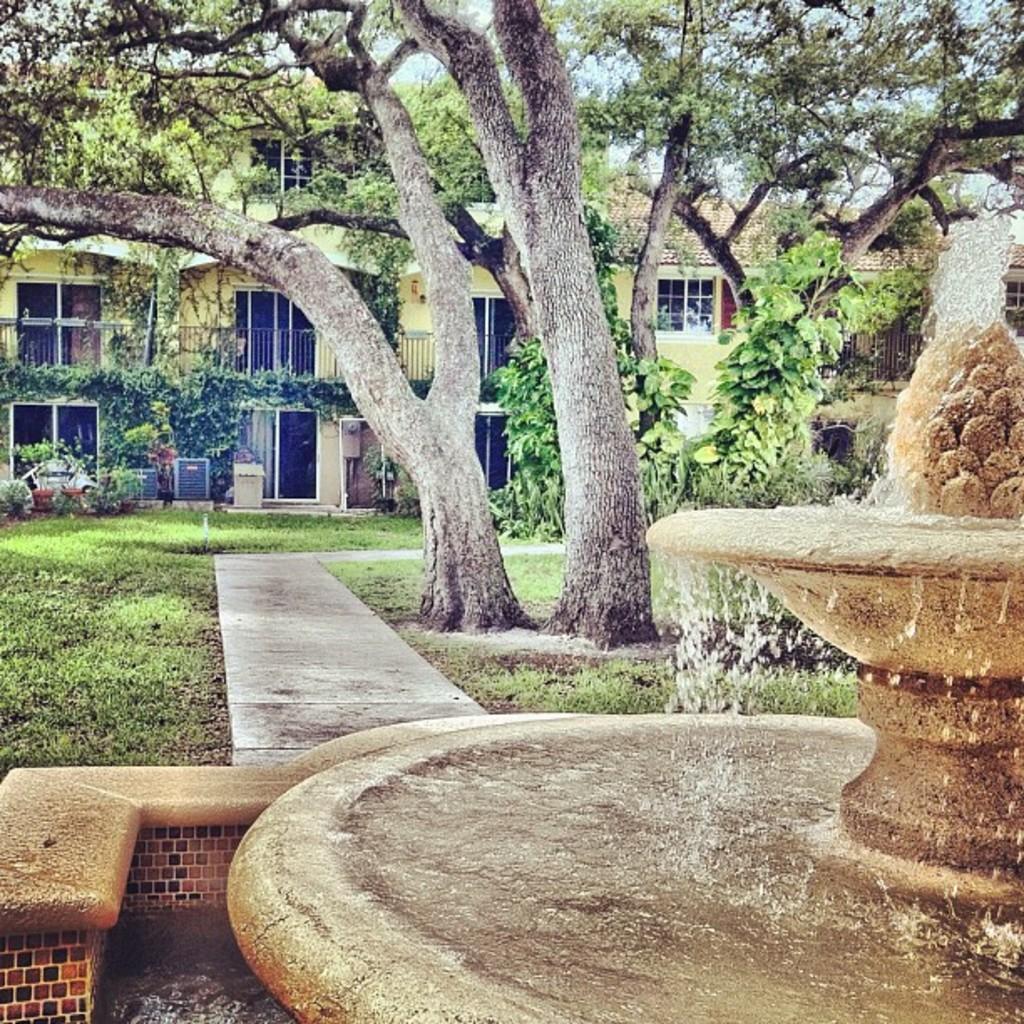Could you give a brief overview of what you see in this image? We can see grassy land and trees in the middle of this image. We can see a building in the background. There is a water fountain at the bottom of this image. 